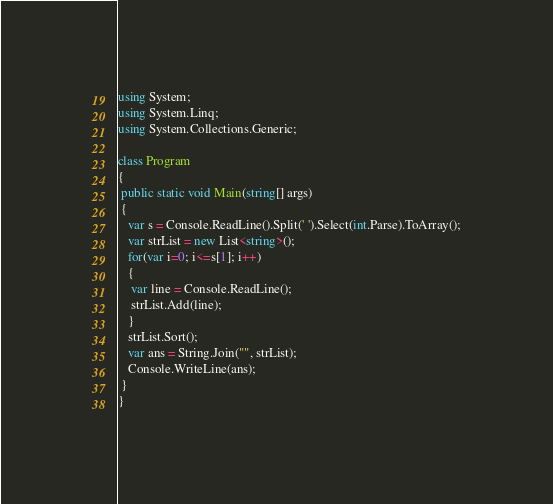<code> <loc_0><loc_0><loc_500><loc_500><_C#_>using System;
using System.Linq;
using System.Collections.Generic;

class Program
{
 public static void Main(string[] args)
 {
   var s = Console.ReadLine().Split(' ').Select(int.Parse).ToArray();
   var strList = new List<string>();
   for(var i=0; i<=s[1]; i++)
   {
    var line = Console.ReadLine();
    strList.Add(line);
   }
   strList.Sort();
   var ans = String.Join("", strList);
   Console.WriteLine(ans);
 }
}</code> 